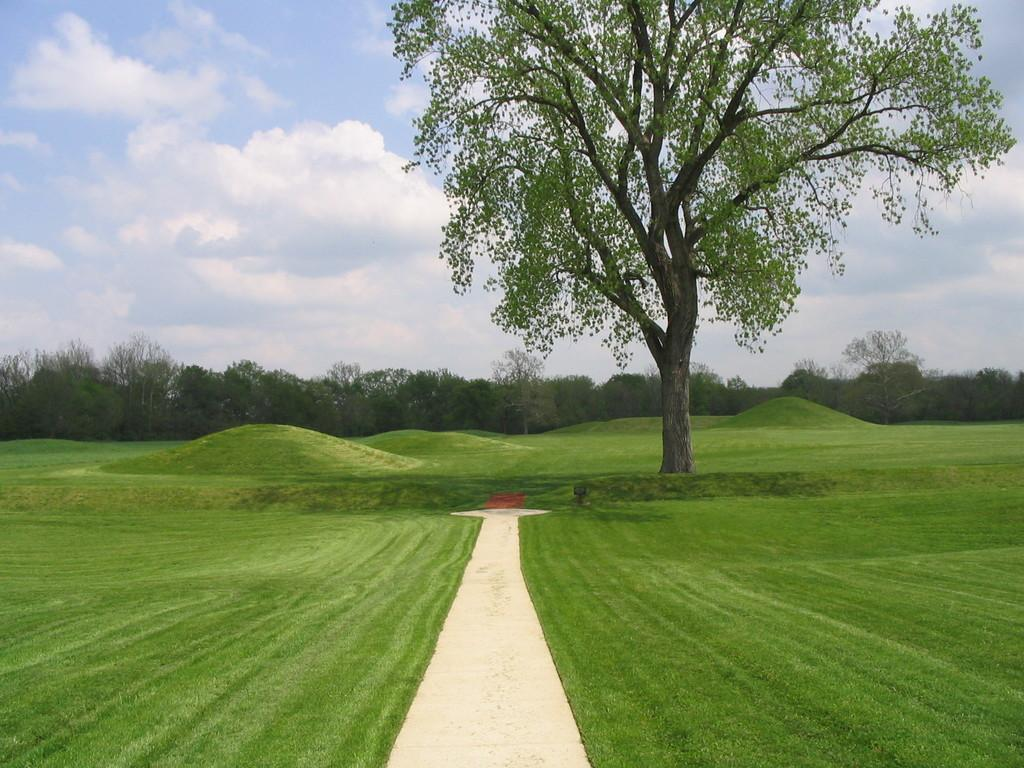What types of surfaces are visible at the bottom of the image? There is grass and pavement at the bottom of the image. What can be seen in the middle of the image? There is a tree in the middle of the image. What is visible in the background of the image? There are trees in the background of the image. What part of the natural environment is visible at the bottom of the image? The sky is visible at the bottom of the image. What can be seen in the sky? Clouds are present in the sky. What type of pen is being used to draw the clouds in the image? There is no pen present in the image, and the clouds are not drawn; they are a natural part of the sky. How many feet are visible in the image? There are no feet visible in the image. 